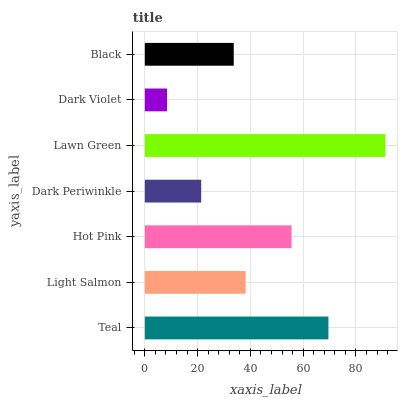Is Dark Violet the minimum?
Answer yes or no. Yes. Is Lawn Green the maximum?
Answer yes or no. Yes. Is Light Salmon the minimum?
Answer yes or no. No. Is Light Salmon the maximum?
Answer yes or no. No. Is Teal greater than Light Salmon?
Answer yes or no. Yes. Is Light Salmon less than Teal?
Answer yes or no. Yes. Is Light Salmon greater than Teal?
Answer yes or no. No. Is Teal less than Light Salmon?
Answer yes or no. No. Is Light Salmon the high median?
Answer yes or no. Yes. Is Light Salmon the low median?
Answer yes or no. Yes. Is Teal the high median?
Answer yes or no. No. Is Lawn Green the low median?
Answer yes or no. No. 